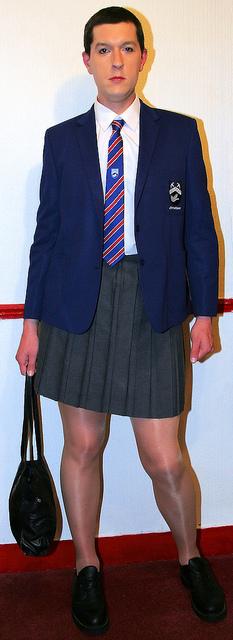What kind of outfit does this woman wear?
Concise answer only. School uniform. Is this a man or a woman?
Give a very brief answer. Man. Is this person wearing leggings?
Give a very brief answer. No. 